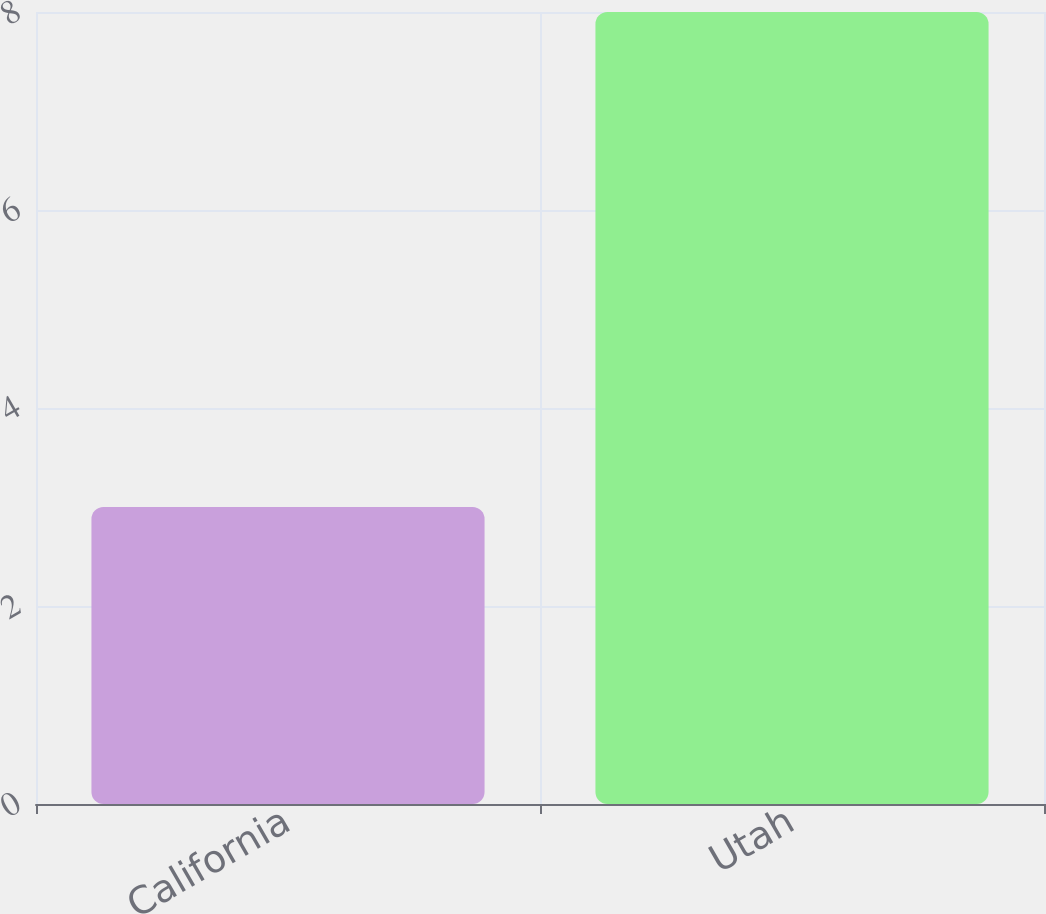Convert chart. <chart><loc_0><loc_0><loc_500><loc_500><bar_chart><fcel>California<fcel>Utah<nl><fcel>3<fcel>8<nl></chart> 